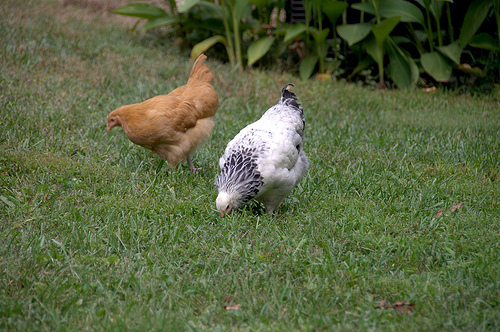<image>
Is the chicken on the grass? Yes. Looking at the image, I can see the chicken is positioned on top of the grass, with the grass providing support. Is the chick in the grass? Yes. The chick is contained within or inside the grass, showing a containment relationship. Is there a chicken in front of the chicken? No. The chicken is not in front of the chicken. The spatial positioning shows a different relationship between these objects. 